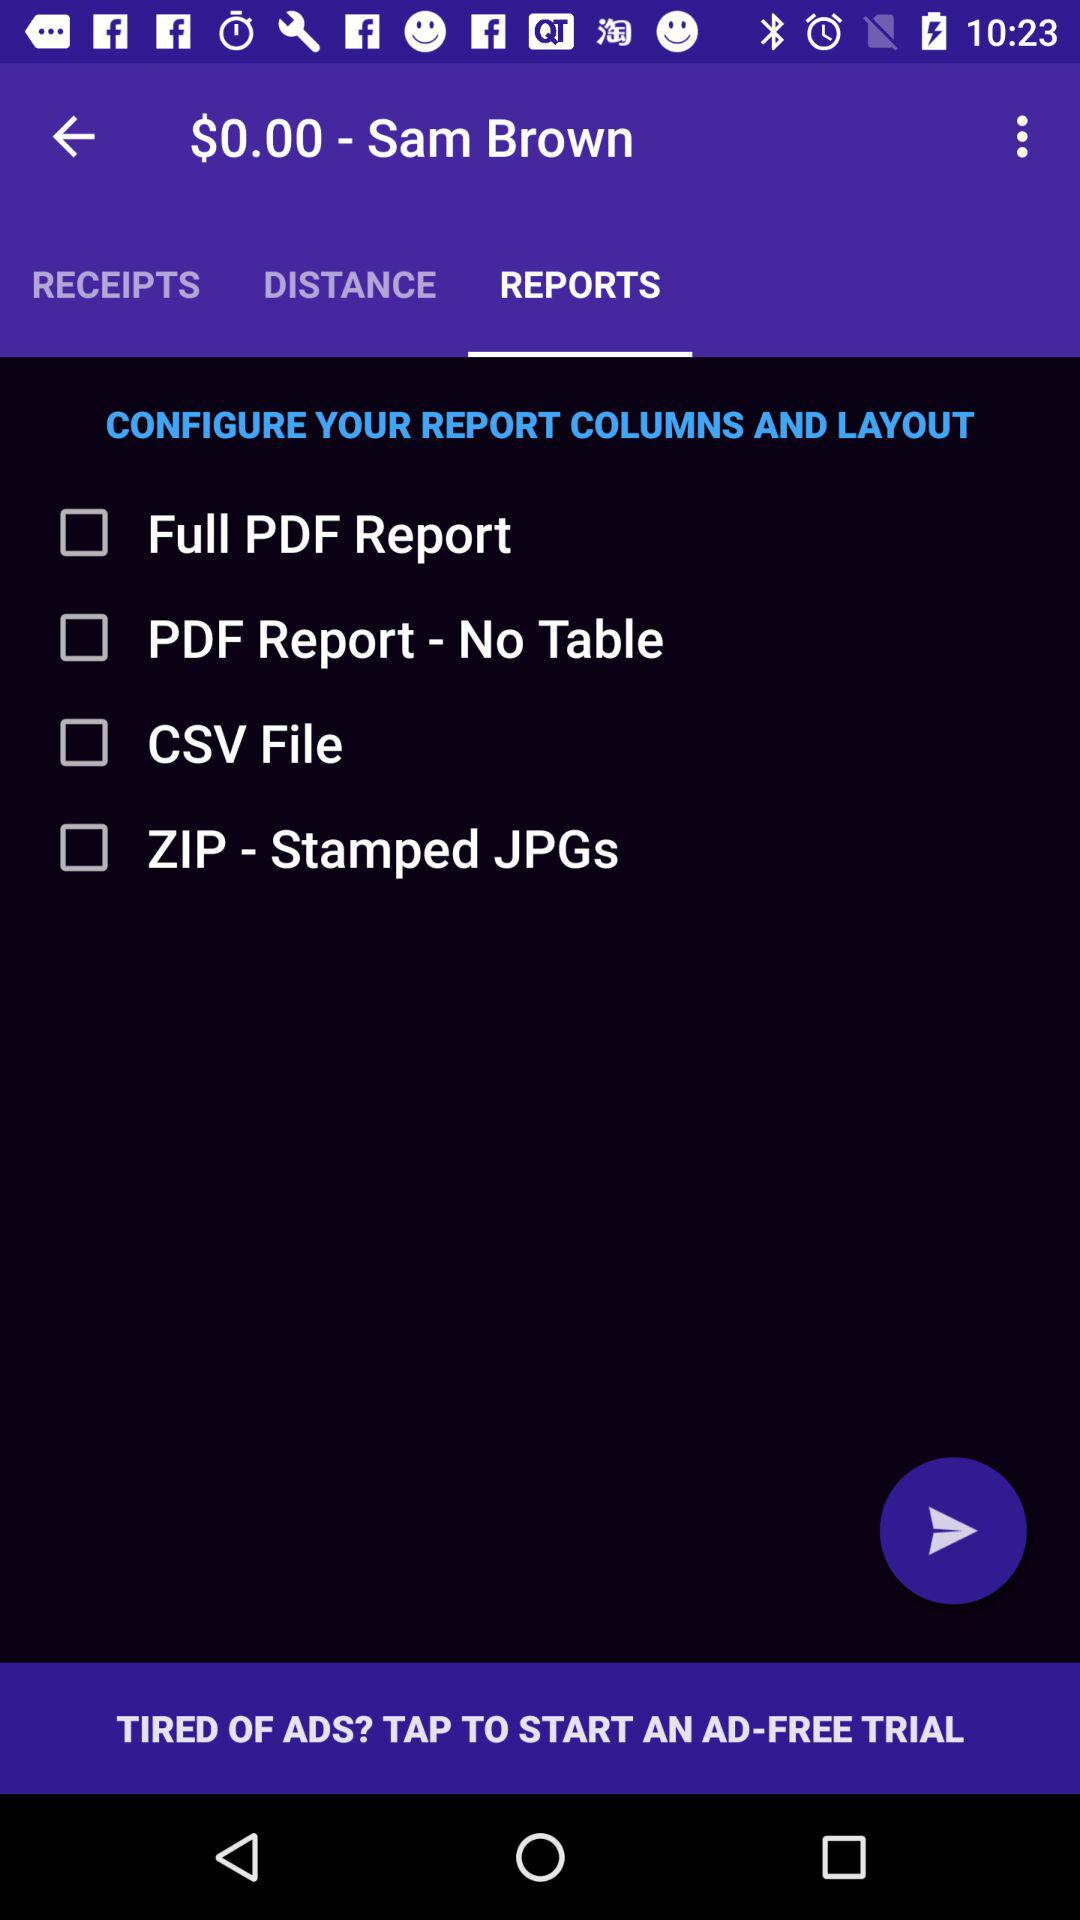What are the options can I check to configure my report? The options that you can check are "Full PDF Report", "PDF Report - No Table", "CSV File" and "ZIP-Stamped JPGs". 